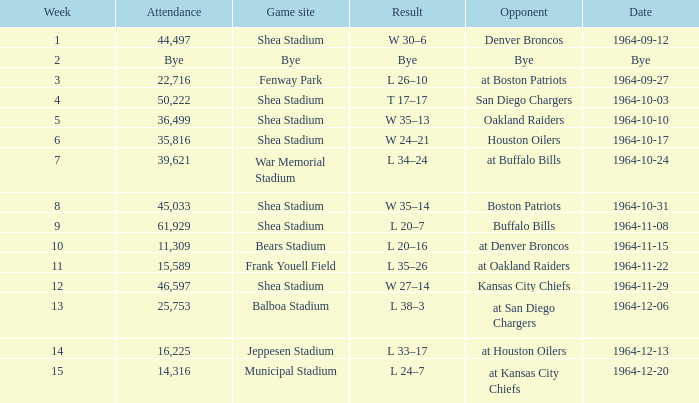Where did the Jet's play with an attendance of 11,309? Bears Stadium. 